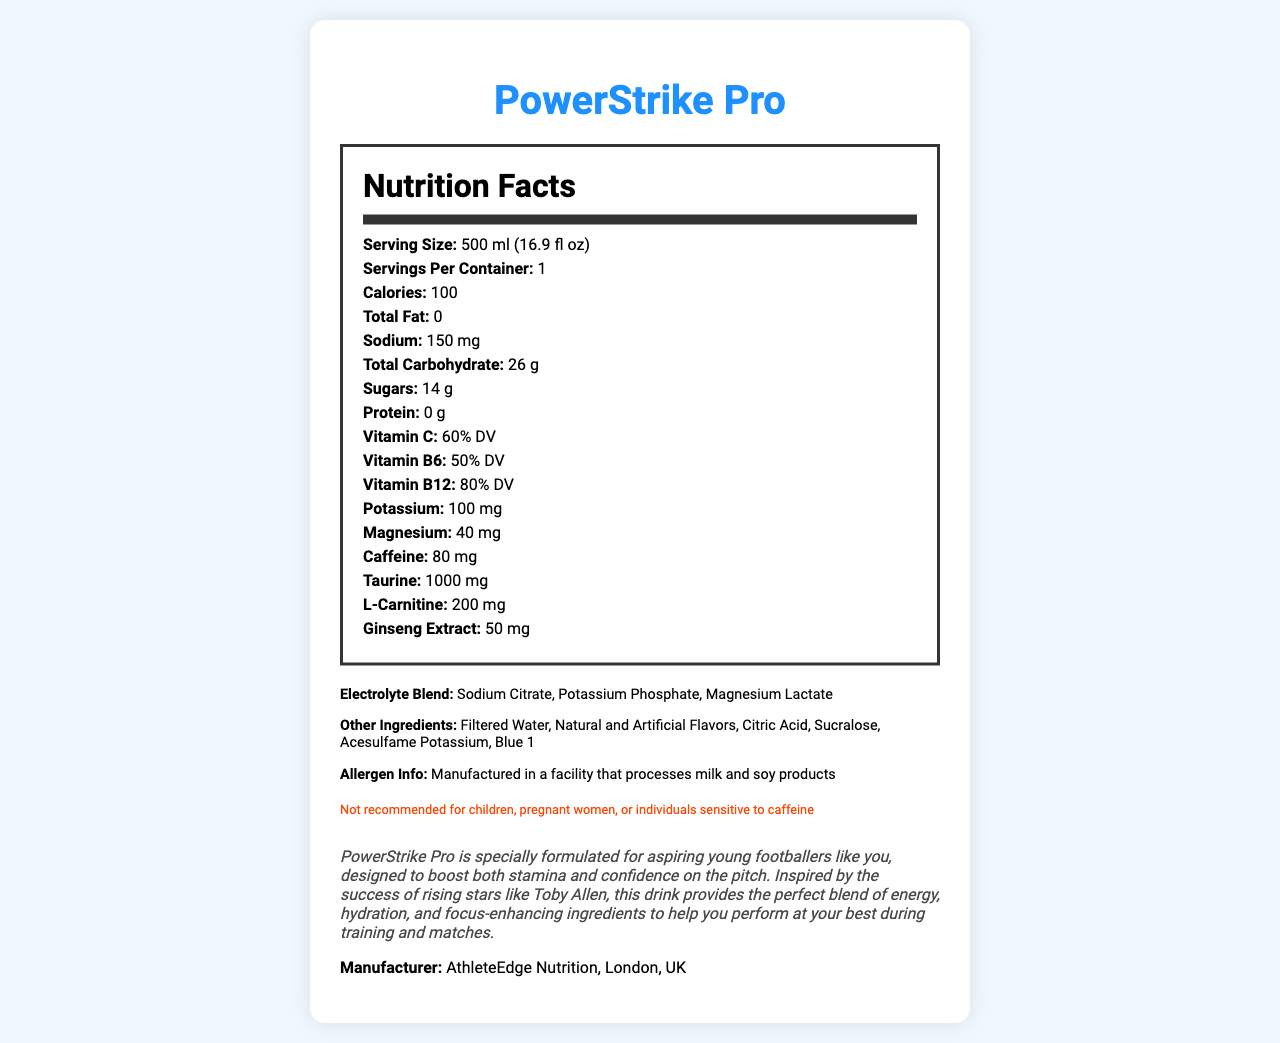Who manufactures PowerStrike Pro? The manufacturer is mentioned at the end of the document: "Manufacturer: AthleteEdge Nutrition, London, UK."
Answer: AthleteEdge Nutrition, London, UK How many calories are in one serving? The document states that the product contains 100 calories per serving.
Answer: 100 calories What is the serving size of PowerStrike Pro? The serving size is given as "500 ml (16.9 fl oz)."
Answer: 500 ml (16.9 fl oz) How much sodium is in one serving? The document lists sodium content as "150 mg."
Answer: 150 mg What percentage of the Daily Value (DV) of Vitamin B12 does PowerStrike Pro provide? According to the document, Vitamin B12 is listed as providing 80% DV.
Answer: 80% DV What is the main benefit claimed by the story in the document? A. Weight Loss B. Boosting stamina and confidence C. Muscle Building D. Improved Digestion The story claims that PowerStrike Pro is designed to boost both stamina and confidence, specifically for aspiring young footballers.
Answer: B: Boosting stamina and confidence Which of the following ingredients is part of the electrolyte blend? A. Sucralose B. Potassium Phosphate C. Ginseng Extract D. Vitamin C The electrolyte blend includes Sodium Citrate, Potassium Phosphate, and Magnesium Lactate.
Answer: B: Potassium Phosphate Can pregnant women consume PowerStrike Pro? The disclaimer section clearly states, "Not recommended for children, pregnant women, or individuals sensitive to caffeine."
Answer: No Summarize the main idea of the document. The document details the key nutritional facts about PowerStrike Pro, emphasizing its benefits for aspiring footballers. It lists ingredients, serving sizes, and disclaimers, focusing on its role in boosting stamina and confidence.
Answer: PowerStrike Pro is a sports drink formulated to enhance stamina and confidence in young footballers, inspired by rising stars like Toby Allen. It provides energy, hydration, and focus-enhancing ingredients, including vitamins, electrolytes, and extra compounds like taurine, ginseng extract, and caffeine. It contains 100 calories per serving and includes essential nutrients but is not recommended for children, pregnant women, or those sensitive to caffeine. Does PowerStrike Pro contain any allergens? The document includes an allergen information section: "Manufactured in a facility that processes milk and soy products."
Answer: Yes How much L-Carnitine does PowerStrike Pro contain? It mentions that the product contains 200 mg of L-Carnitine per serving.
Answer: 200 mg Is PowerStrike Pro suitable for young children? The disclaimer clearly states, "Not recommended for children."
Answer: No What flavors are used in PowerStrike Pro? The document lists "Natural and Artificial Flavors" in the other ingredients section.
Answer: Natural and Artificial Flavors What is the main intended audience for PowerStrike Pro according to the story? The story states that PowerStrike Pro is specially formulated for aspiring young footballers.
Answer: Aspiring young footballers How much Taurine does one serving of PowerStrike Pro contain? The document specifies that Taurine content is 1000 mg.
Answer: 1000 mg What color is used in PowerStrike Pro? The document lists Blue 1 among the other ingredients.
Answer: Blue 1 What is the total carbohydrate content? The document lists total carbohydrate content as 26 g.
Answer: 26 g When was the company that produces PowerStrike Pro founded? The document does not provide the founding date of AthleteEdge Nutrition.
Answer: Not enough information 